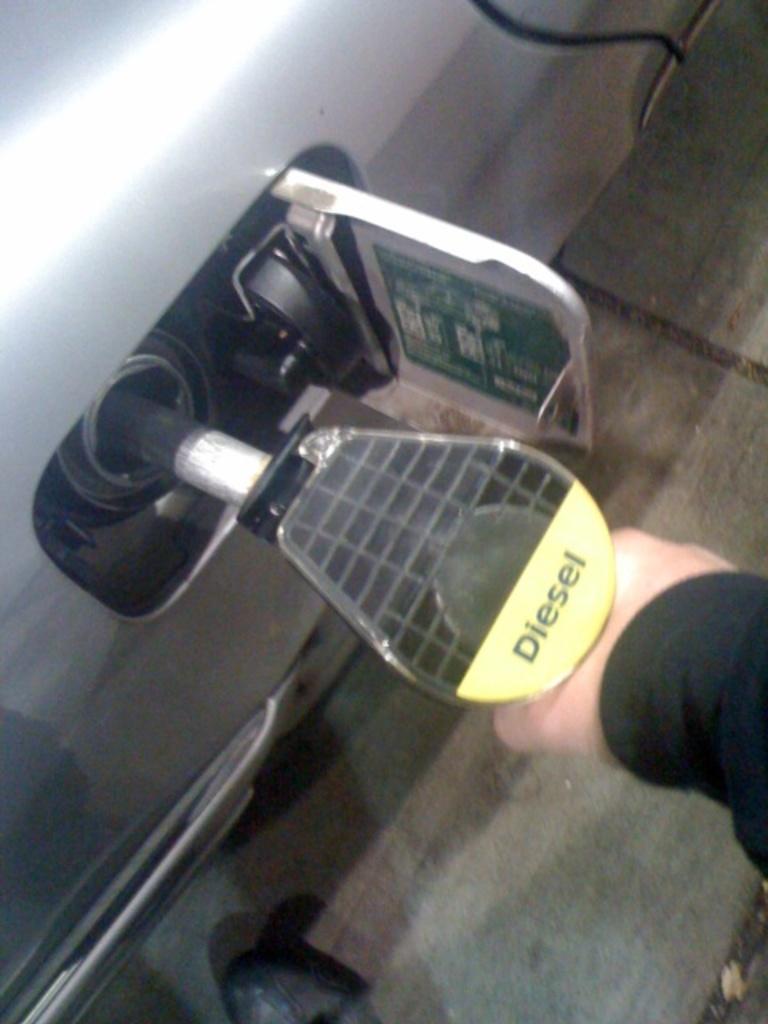Describe this image in one or two sentences. This image is taken in a petrol bunk. On the left side of the image a car is parked on the road and a fuel tank is opened. On the right side of the image a man is standing on the floor and filling diesel, holding a diesel pipe in his hand. 